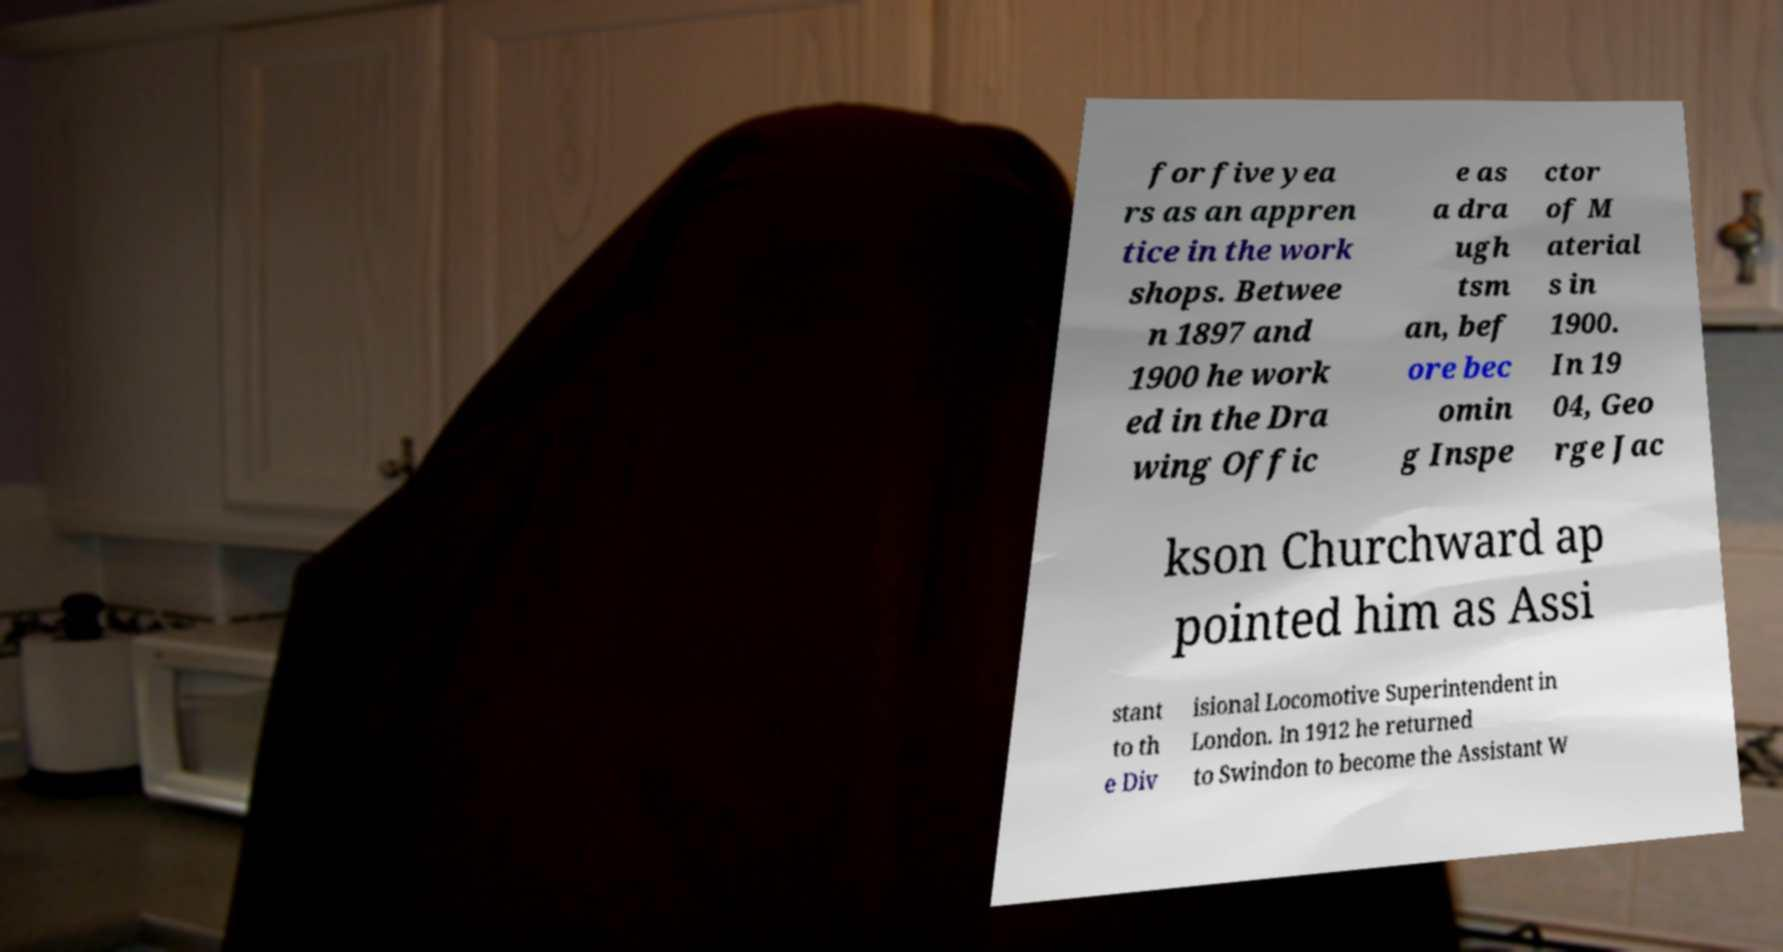Can you read and provide the text displayed in the image?This photo seems to have some interesting text. Can you extract and type it out for me? for five yea rs as an appren tice in the work shops. Betwee n 1897 and 1900 he work ed in the Dra wing Offic e as a dra ugh tsm an, bef ore bec omin g Inspe ctor of M aterial s in 1900. In 19 04, Geo rge Jac kson Churchward ap pointed him as Assi stant to th e Div isional Locomotive Superintendent in London. In 1912 he returned to Swindon to become the Assistant W 